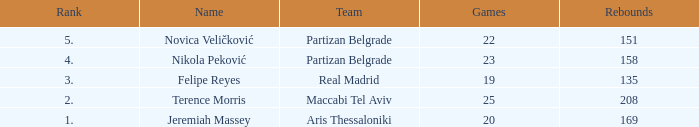How many Games for Terence Morris? 25.0. 